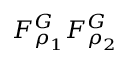Convert formula to latex. <formula><loc_0><loc_0><loc_500><loc_500>F _ { \rho _ { 1 } } ^ { G } F _ { \rho _ { 2 } } ^ { G }</formula> 